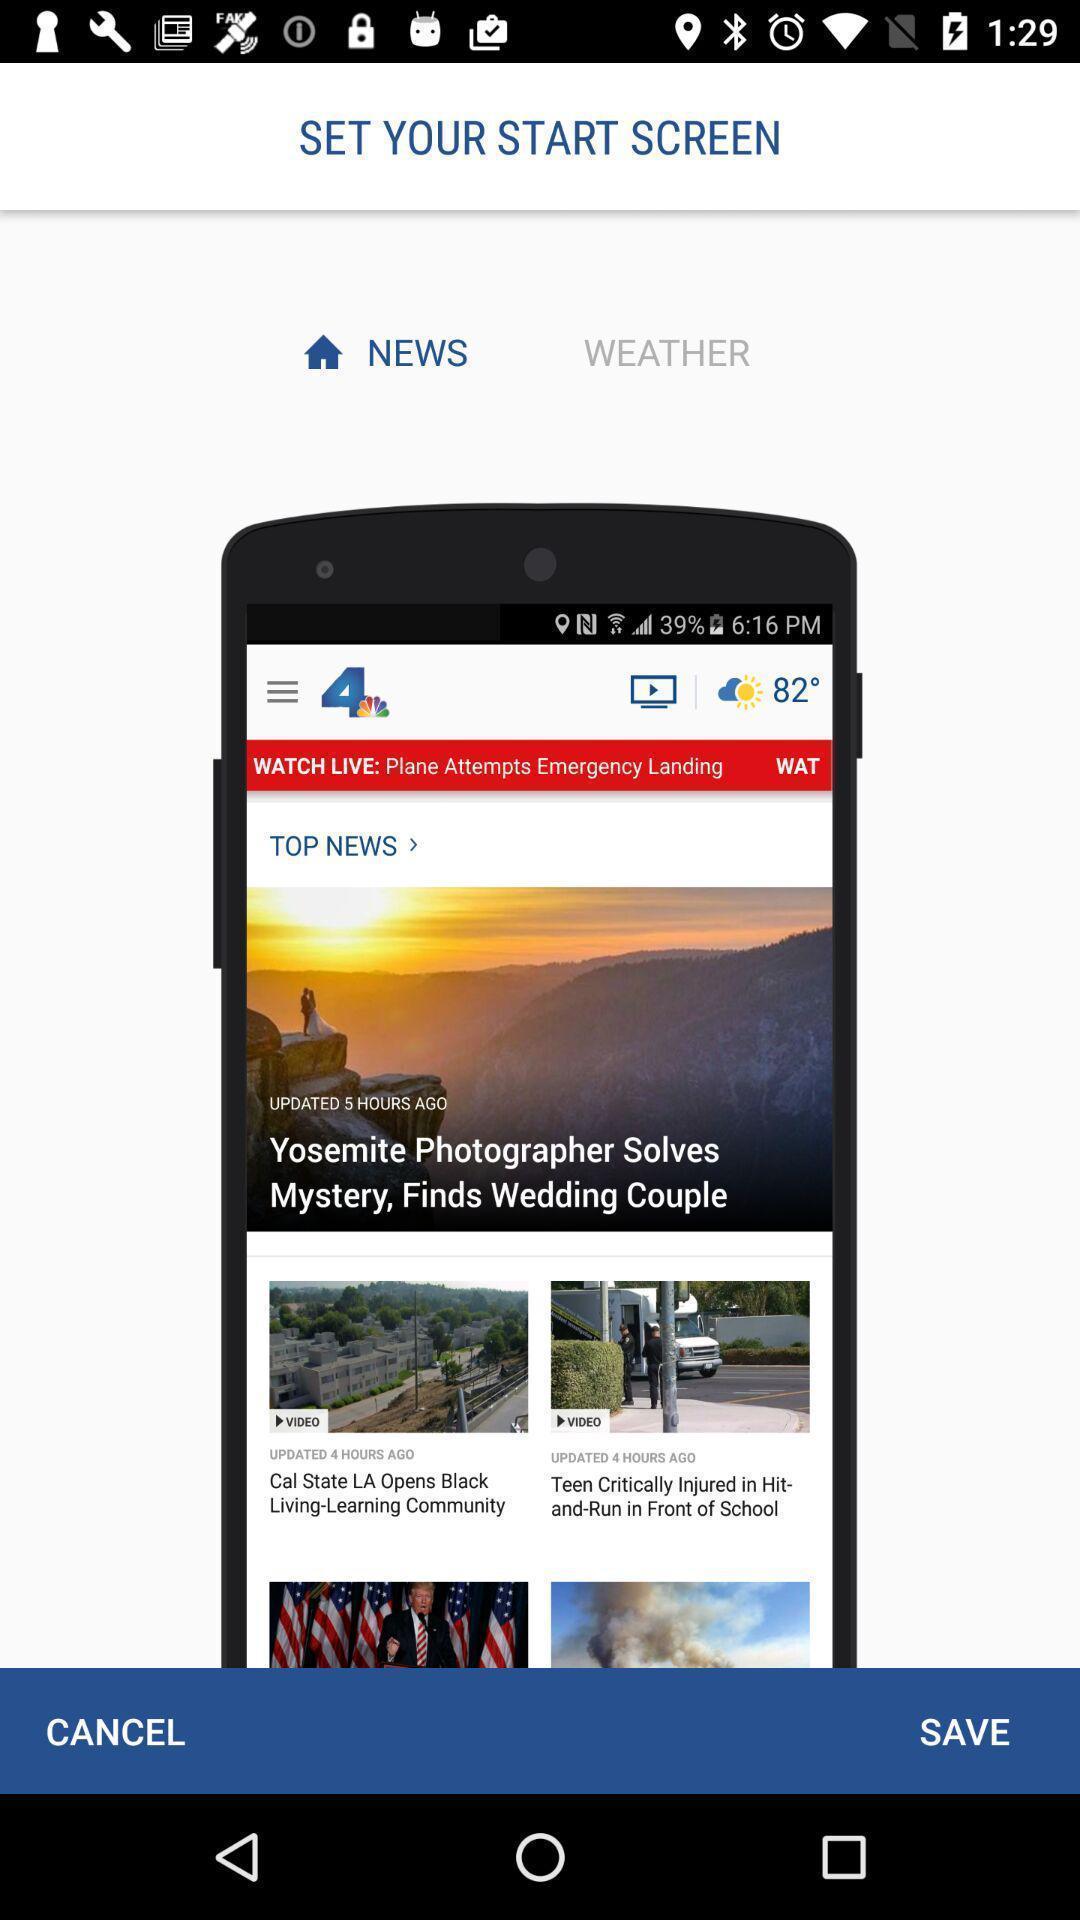Provide a textual representation of this image. Welcome page for a news streaming app. 